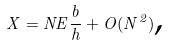Convert formula to latex. <formula><loc_0><loc_0><loc_500><loc_500>X = N E \frac { b } { h } + O ( N ^ { 2 } ) \text {,}</formula> 